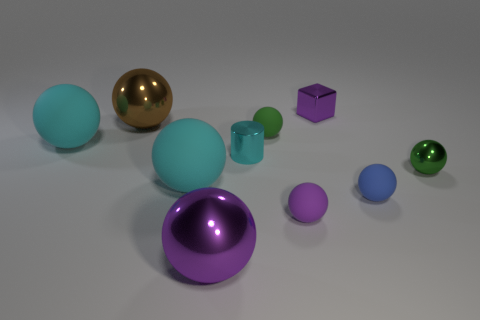Subtract all small green balls. How many balls are left? 6 Subtract all cubes. How many objects are left? 9 Subtract all purple spheres. How many spheres are left? 6 Subtract 3 spheres. How many spheres are left? 5 Subtract all small shiny balls. Subtract all tiny metal objects. How many objects are left? 6 Add 5 brown shiny objects. How many brown shiny objects are left? 6 Add 4 big brown matte objects. How many big brown matte objects exist? 4 Subtract 0 green cylinders. How many objects are left? 10 Subtract all yellow spheres. Subtract all purple cylinders. How many spheres are left? 8 Subtract all red blocks. How many yellow cylinders are left? 0 